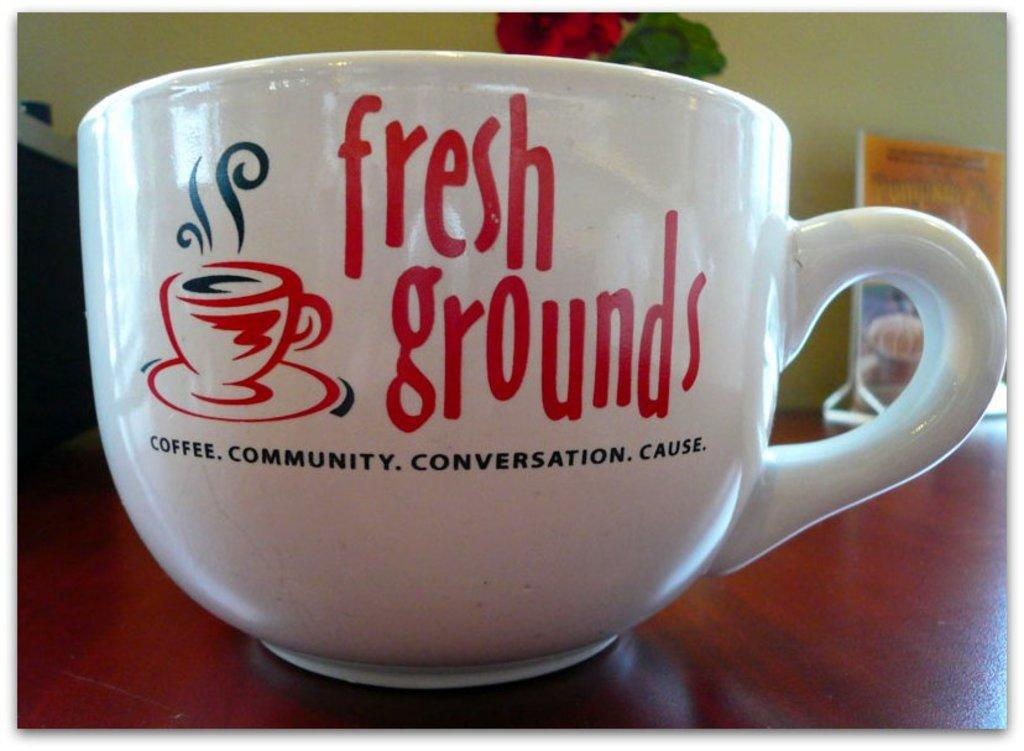<image>
Give a short and clear explanation of the subsequent image. A large white Fresh Grounds advertisement coffee mug on a wooden table. 